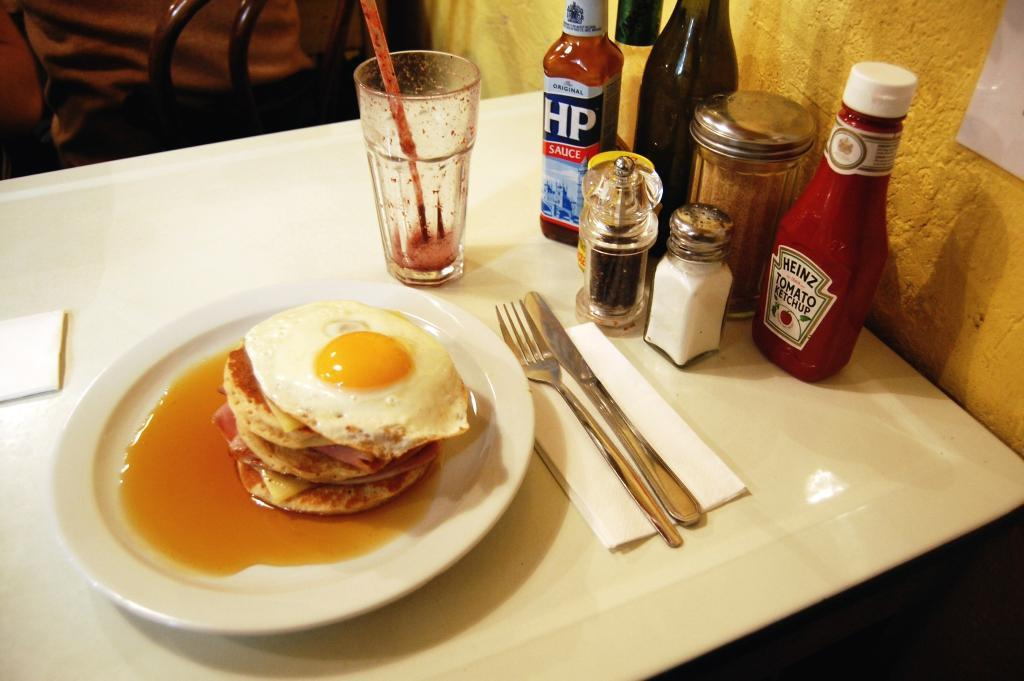What is the main object in the center of the image? There is a table in the middle of the image. What items can be seen on the table? On the table, there is a plate, a glass, a fork, and tissues. Are there any other items on the table? Yes, there are other items on the table. What can be seen in the background of the image? In the background, there is a chair and a wall. What type of apparatus is being used by the crowd of dogs in the image? There is no apparatus or crowd of dogs present in the image. 